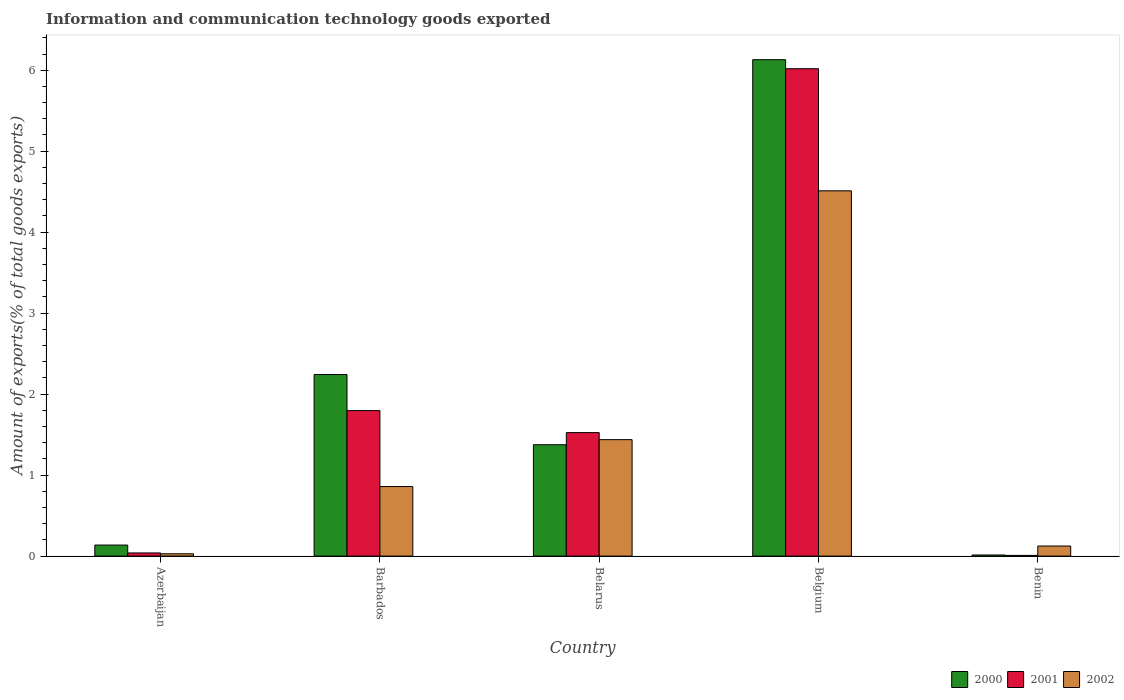How many different coloured bars are there?
Your answer should be compact. 3. How many bars are there on the 3rd tick from the right?
Your response must be concise. 3. What is the label of the 4th group of bars from the left?
Your answer should be very brief. Belgium. What is the amount of goods exported in 2002 in Benin?
Make the answer very short. 0.12. Across all countries, what is the maximum amount of goods exported in 2000?
Give a very brief answer. 6.13. Across all countries, what is the minimum amount of goods exported in 2002?
Offer a terse response. 0.03. In which country was the amount of goods exported in 2000 minimum?
Provide a short and direct response. Benin. What is the total amount of goods exported in 2002 in the graph?
Your response must be concise. 6.96. What is the difference between the amount of goods exported in 2000 in Barbados and that in Belgium?
Offer a very short reply. -3.89. What is the difference between the amount of goods exported in 2001 in Benin and the amount of goods exported in 2000 in Azerbaijan?
Give a very brief answer. -0.13. What is the average amount of goods exported in 2000 per country?
Ensure brevity in your answer.  1.98. What is the difference between the amount of goods exported of/in 2002 and amount of goods exported of/in 2001 in Belgium?
Give a very brief answer. -1.51. In how many countries, is the amount of goods exported in 2001 greater than 1.6 %?
Provide a succinct answer. 2. What is the ratio of the amount of goods exported in 2000 in Belgium to that in Benin?
Your answer should be compact. 443.09. Is the amount of goods exported in 2002 in Belarus less than that in Benin?
Give a very brief answer. No. What is the difference between the highest and the second highest amount of goods exported in 2001?
Offer a terse response. -0.27. What is the difference between the highest and the lowest amount of goods exported in 2002?
Your response must be concise. 4.48. In how many countries, is the amount of goods exported in 2000 greater than the average amount of goods exported in 2000 taken over all countries?
Keep it short and to the point. 2. What does the 1st bar from the left in Belgium represents?
Make the answer very short. 2000. Is it the case that in every country, the sum of the amount of goods exported in 2000 and amount of goods exported in 2001 is greater than the amount of goods exported in 2002?
Make the answer very short. No. How many bars are there?
Provide a succinct answer. 15. Are all the bars in the graph horizontal?
Make the answer very short. No. What is the difference between two consecutive major ticks on the Y-axis?
Keep it short and to the point. 1. Are the values on the major ticks of Y-axis written in scientific E-notation?
Provide a short and direct response. No. Where does the legend appear in the graph?
Your response must be concise. Bottom right. How are the legend labels stacked?
Your response must be concise. Horizontal. What is the title of the graph?
Keep it short and to the point. Information and communication technology goods exported. What is the label or title of the X-axis?
Make the answer very short. Country. What is the label or title of the Y-axis?
Your response must be concise. Amount of exports(% of total goods exports). What is the Amount of exports(% of total goods exports) in 2000 in Azerbaijan?
Give a very brief answer. 0.14. What is the Amount of exports(% of total goods exports) in 2001 in Azerbaijan?
Your answer should be very brief. 0.04. What is the Amount of exports(% of total goods exports) in 2002 in Azerbaijan?
Your response must be concise. 0.03. What is the Amount of exports(% of total goods exports) of 2000 in Barbados?
Your answer should be very brief. 2.24. What is the Amount of exports(% of total goods exports) in 2001 in Barbados?
Give a very brief answer. 1.8. What is the Amount of exports(% of total goods exports) of 2002 in Barbados?
Your response must be concise. 0.86. What is the Amount of exports(% of total goods exports) in 2000 in Belarus?
Your answer should be compact. 1.38. What is the Amount of exports(% of total goods exports) of 2001 in Belarus?
Offer a terse response. 1.53. What is the Amount of exports(% of total goods exports) of 2002 in Belarus?
Your response must be concise. 1.44. What is the Amount of exports(% of total goods exports) of 2000 in Belgium?
Ensure brevity in your answer.  6.13. What is the Amount of exports(% of total goods exports) in 2001 in Belgium?
Offer a terse response. 6.02. What is the Amount of exports(% of total goods exports) in 2002 in Belgium?
Keep it short and to the point. 4.51. What is the Amount of exports(% of total goods exports) in 2000 in Benin?
Make the answer very short. 0.01. What is the Amount of exports(% of total goods exports) of 2001 in Benin?
Make the answer very short. 0.01. What is the Amount of exports(% of total goods exports) of 2002 in Benin?
Offer a terse response. 0.12. Across all countries, what is the maximum Amount of exports(% of total goods exports) in 2000?
Offer a terse response. 6.13. Across all countries, what is the maximum Amount of exports(% of total goods exports) in 2001?
Provide a short and direct response. 6.02. Across all countries, what is the maximum Amount of exports(% of total goods exports) in 2002?
Provide a short and direct response. 4.51. Across all countries, what is the minimum Amount of exports(% of total goods exports) in 2000?
Provide a short and direct response. 0.01. Across all countries, what is the minimum Amount of exports(% of total goods exports) in 2001?
Your answer should be very brief. 0.01. Across all countries, what is the minimum Amount of exports(% of total goods exports) of 2002?
Offer a very short reply. 0.03. What is the total Amount of exports(% of total goods exports) of 2000 in the graph?
Your response must be concise. 9.9. What is the total Amount of exports(% of total goods exports) of 2001 in the graph?
Your response must be concise. 9.39. What is the total Amount of exports(% of total goods exports) in 2002 in the graph?
Your answer should be compact. 6.96. What is the difference between the Amount of exports(% of total goods exports) in 2000 in Azerbaijan and that in Barbados?
Ensure brevity in your answer.  -2.11. What is the difference between the Amount of exports(% of total goods exports) in 2001 in Azerbaijan and that in Barbados?
Provide a succinct answer. -1.76. What is the difference between the Amount of exports(% of total goods exports) of 2002 in Azerbaijan and that in Barbados?
Offer a very short reply. -0.83. What is the difference between the Amount of exports(% of total goods exports) of 2000 in Azerbaijan and that in Belarus?
Make the answer very short. -1.24. What is the difference between the Amount of exports(% of total goods exports) in 2001 in Azerbaijan and that in Belarus?
Give a very brief answer. -1.49. What is the difference between the Amount of exports(% of total goods exports) in 2002 in Azerbaijan and that in Belarus?
Ensure brevity in your answer.  -1.41. What is the difference between the Amount of exports(% of total goods exports) in 2000 in Azerbaijan and that in Belgium?
Offer a very short reply. -5.99. What is the difference between the Amount of exports(% of total goods exports) of 2001 in Azerbaijan and that in Belgium?
Your answer should be very brief. -5.98. What is the difference between the Amount of exports(% of total goods exports) in 2002 in Azerbaijan and that in Belgium?
Your response must be concise. -4.48. What is the difference between the Amount of exports(% of total goods exports) of 2000 in Azerbaijan and that in Benin?
Your answer should be very brief. 0.12. What is the difference between the Amount of exports(% of total goods exports) of 2001 in Azerbaijan and that in Benin?
Provide a succinct answer. 0.03. What is the difference between the Amount of exports(% of total goods exports) of 2002 in Azerbaijan and that in Benin?
Give a very brief answer. -0.1. What is the difference between the Amount of exports(% of total goods exports) of 2000 in Barbados and that in Belarus?
Make the answer very short. 0.87. What is the difference between the Amount of exports(% of total goods exports) of 2001 in Barbados and that in Belarus?
Your response must be concise. 0.27. What is the difference between the Amount of exports(% of total goods exports) of 2002 in Barbados and that in Belarus?
Make the answer very short. -0.58. What is the difference between the Amount of exports(% of total goods exports) of 2000 in Barbados and that in Belgium?
Give a very brief answer. -3.89. What is the difference between the Amount of exports(% of total goods exports) of 2001 in Barbados and that in Belgium?
Keep it short and to the point. -4.22. What is the difference between the Amount of exports(% of total goods exports) of 2002 in Barbados and that in Belgium?
Provide a succinct answer. -3.65. What is the difference between the Amount of exports(% of total goods exports) in 2000 in Barbados and that in Benin?
Make the answer very short. 2.23. What is the difference between the Amount of exports(% of total goods exports) of 2001 in Barbados and that in Benin?
Your answer should be very brief. 1.79. What is the difference between the Amount of exports(% of total goods exports) of 2002 in Barbados and that in Benin?
Keep it short and to the point. 0.73. What is the difference between the Amount of exports(% of total goods exports) in 2000 in Belarus and that in Belgium?
Your answer should be very brief. -4.75. What is the difference between the Amount of exports(% of total goods exports) in 2001 in Belarus and that in Belgium?
Provide a short and direct response. -4.49. What is the difference between the Amount of exports(% of total goods exports) of 2002 in Belarus and that in Belgium?
Keep it short and to the point. -3.07. What is the difference between the Amount of exports(% of total goods exports) in 2000 in Belarus and that in Benin?
Offer a very short reply. 1.36. What is the difference between the Amount of exports(% of total goods exports) of 2001 in Belarus and that in Benin?
Your response must be concise. 1.52. What is the difference between the Amount of exports(% of total goods exports) of 2002 in Belarus and that in Benin?
Your answer should be very brief. 1.31. What is the difference between the Amount of exports(% of total goods exports) of 2000 in Belgium and that in Benin?
Provide a succinct answer. 6.12. What is the difference between the Amount of exports(% of total goods exports) in 2001 in Belgium and that in Benin?
Keep it short and to the point. 6.01. What is the difference between the Amount of exports(% of total goods exports) in 2002 in Belgium and that in Benin?
Offer a very short reply. 4.39. What is the difference between the Amount of exports(% of total goods exports) in 2000 in Azerbaijan and the Amount of exports(% of total goods exports) in 2001 in Barbados?
Offer a terse response. -1.66. What is the difference between the Amount of exports(% of total goods exports) of 2000 in Azerbaijan and the Amount of exports(% of total goods exports) of 2002 in Barbados?
Your answer should be compact. -0.72. What is the difference between the Amount of exports(% of total goods exports) in 2001 in Azerbaijan and the Amount of exports(% of total goods exports) in 2002 in Barbados?
Your answer should be compact. -0.82. What is the difference between the Amount of exports(% of total goods exports) of 2000 in Azerbaijan and the Amount of exports(% of total goods exports) of 2001 in Belarus?
Your response must be concise. -1.39. What is the difference between the Amount of exports(% of total goods exports) in 2000 in Azerbaijan and the Amount of exports(% of total goods exports) in 2002 in Belarus?
Offer a very short reply. -1.3. What is the difference between the Amount of exports(% of total goods exports) in 2001 in Azerbaijan and the Amount of exports(% of total goods exports) in 2002 in Belarus?
Provide a succinct answer. -1.4. What is the difference between the Amount of exports(% of total goods exports) in 2000 in Azerbaijan and the Amount of exports(% of total goods exports) in 2001 in Belgium?
Offer a terse response. -5.88. What is the difference between the Amount of exports(% of total goods exports) in 2000 in Azerbaijan and the Amount of exports(% of total goods exports) in 2002 in Belgium?
Offer a terse response. -4.37. What is the difference between the Amount of exports(% of total goods exports) in 2001 in Azerbaijan and the Amount of exports(% of total goods exports) in 2002 in Belgium?
Your answer should be compact. -4.47. What is the difference between the Amount of exports(% of total goods exports) in 2000 in Azerbaijan and the Amount of exports(% of total goods exports) in 2001 in Benin?
Provide a succinct answer. 0.13. What is the difference between the Amount of exports(% of total goods exports) in 2000 in Azerbaijan and the Amount of exports(% of total goods exports) in 2002 in Benin?
Keep it short and to the point. 0.01. What is the difference between the Amount of exports(% of total goods exports) of 2001 in Azerbaijan and the Amount of exports(% of total goods exports) of 2002 in Benin?
Your answer should be very brief. -0.09. What is the difference between the Amount of exports(% of total goods exports) of 2000 in Barbados and the Amount of exports(% of total goods exports) of 2001 in Belarus?
Ensure brevity in your answer.  0.72. What is the difference between the Amount of exports(% of total goods exports) in 2000 in Barbados and the Amount of exports(% of total goods exports) in 2002 in Belarus?
Your response must be concise. 0.8. What is the difference between the Amount of exports(% of total goods exports) of 2001 in Barbados and the Amount of exports(% of total goods exports) of 2002 in Belarus?
Provide a short and direct response. 0.36. What is the difference between the Amount of exports(% of total goods exports) of 2000 in Barbados and the Amount of exports(% of total goods exports) of 2001 in Belgium?
Make the answer very short. -3.78. What is the difference between the Amount of exports(% of total goods exports) of 2000 in Barbados and the Amount of exports(% of total goods exports) of 2002 in Belgium?
Provide a succinct answer. -2.27. What is the difference between the Amount of exports(% of total goods exports) in 2001 in Barbados and the Amount of exports(% of total goods exports) in 2002 in Belgium?
Provide a short and direct response. -2.71. What is the difference between the Amount of exports(% of total goods exports) in 2000 in Barbados and the Amount of exports(% of total goods exports) in 2001 in Benin?
Offer a very short reply. 2.23. What is the difference between the Amount of exports(% of total goods exports) in 2000 in Barbados and the Amount of exports(% of total goods exports) in 2002 in Benin?
Your answer should be very brief. 2.12. What is the difference between the Amount of exports(% of total goods exports) in 2001 in Barbados and the Amount of exports(% of total goods exports) in 2002 in Benin?
Your answer should be very brief. 1.67. What is the difference between the Amount of exports(% of total goods exports) of 2000 in Belarus and the Amount of exports(% of total goods exports) of 2001 in Belgium?
Your answer should be very brief. -4.64. What is the difference between the Amount of exports(% of total goods exports) in 2000 in Belarus and the Amount of exports(% of total goods exports) in 2002 in Belgium?
Give a very brief answer. -3.14. What is the difference between the Amount of exports(% of total goods exports) in 2001 in Belarus and the Amount of exports(% of total goods exports) in 2002 in Belgium?
Give a very brief answer. -2.99. What is the difference between the Amount of exports(% of total goods exports) in 2000 in Belarus and the Amount of exports(% of total goods exports) in 2001 in Benin?
Offer a very short reply. 1.37. What is the difference between the Amount of exports(% of total goods exports) of 2000 in Belarus and the Amount of exports(% of total goods exports) of 2002 in Benin?
Keep it short and to the point. 1.25. What is the difference between the Amount of exports(% of total goods exports) of 2001 in Belarus and the Amount of exports(% of total goods exports) of 2002 in Benin?
Offer a very short reply. 1.4. What is the difference between the Amount of exports(% of total goods exports) in 2000 in Belgium and the Amount of exports(% of total goods exports) in 2001 in Benin?
Keep it short and to the point. 6.12. What is the difference between the Amount of exports(% of total goods exports) of 2000 in Belgium and the Amount of exports(% of total goods exports) of 2002 in Benin?
Offer a very short reply. 6.01. What is the difference between the Amount of exports(% of total goods exports) of 2001 in Belgium and the Amount of exports(% of total goods exports) of 2002 in Benin?
Ensure brevity in your answer.  5.89. What is the average Amount of exports(% of total goods exports) of 2000 per country?
Ensure brevity in your answer.  1.98. What is the average Amount of exports(% of total goods exports) of 2001 per country?
Keep it short and to the point. 1.88. What is the average Amount of exports(% of total goods exports) in 2002 per country?
Ensure brevity in your answer.  1.39. What is the difference between the Amount of exports(% of total goods exports) of 2000 and Amount of exports(% of total goods exports) of 2001 in Azerbaijan?
Your answer should be compact. 0.1. What is the difference between the Amount of exports(% of total goods exports) in 2000 and Amount of exports(% of total goods exports) in 2002 in Azerbaijan?
Provide a succinct answer. 0.11. What is the difference between the Amount of exports(% of total goods exports) in 2001 and Amount of exports(% of total goods exports) in 2002 in Azerbaijan?
Offer a terse response. 0.01. What is the difference between the Amount of exports(% of total goods exports) in 2000 and Amount of exports(% of total goods exports) in 2001 in Barbados?
Your response must be concise. 0.45. What is the difference between the Amount of exports(% of total goods exports) of 2000 and Amount of exports(% of total goods exports) of 2002 in Barbados?
Offer a terse response. 1.38. What is the difference between the Amount of exports(% of total goods exports) of 2001 and Amount of exports(% of total goods exports) of 2002 in Barbados?
Offer a terse response. 0.94. What is the difference between the Amount of exports(% of total goods exports) of 2000 and Amount of exports(% of total goods exports) of 2001 in Belarus?
Provide a succinct answer. -0.15. What is the difference between the Amount of exports(% of total goods exports) in 2000 and Amount of exports(% of total goods exports) in 2002 in Belarus?
Your response must be concise. -0.06. What is the difference between the Amount of exports(% of total goods exports) of 2001 and Amount of exports(% of total goods exports) of 2002 in Belarus?
Offer a terse response. 0.09. What is the difference between the Amount of exports(% of total goods exports) in 2000 and Amount of exports(% of total goods exports) in 2001 in Belgium?
Your answer should be very brief. 0.11. What is the difference between the Amount of exports(% of total goods exports) of 2000 and Amount of exports(% of total goods exports) of 2002 in Belgium?
Offer a very short reply. 1.62. What is the difference between the Amount of exports(% of total goods exports) in 2001 and Amount of exports(% of total goods exports) in 2002 in Belgium?
Provide a succinct answer. 1.51. What is the difference between the Amount of exports(% of total goods exports) of 2000 and Amount of exports(% of total goods exports) of 2001 in Benin?
Ensure brevity in your answer.  0.01. What is the difference between the Amount of exports(% of total goods exports) in 2000 and Amount of exports(% of total goods exports) in 2002 in Benin?
Ensure brevity in your answer.  -0.11. What is the difference between the Amount of exports(% of total goods exports) in 2001 and Amount of exports(% of total goods exports) in 2002 in Benin?
Your answer should be very brief. -0.12. What is the ratio of the Amount of exports(% of total goods exports) of 2000 in Azerbaijan to that in Barbados?
Keep it short and to the point. 0.06. What is the ratio of the Amount of exports(% of total goods exports) in 2001 in Azerbaijan to that in Barbados?
Keep it short and to the point. 0.02. What is the ratio of the Amount of exports(% of total goods exports) of 2002 in Azerbaijan to that in Barbados?
Offer a very short reply. 0.03. What is the ratio of the Amount of exports(% of total goods exports) in 2000 in Azerbaijan to that in Belarus?
Provide a succinct answer. 0.1. What is the ratio of the Amount of exports(% of total goods exports) of 2001 in Azerbaijan to that in Belarus?
Offer a very short reply. 0.03. What is the ratio of the Amount of exports(% of total goods exports) in 2002 in Azerbaijan to that in Belarus?
Offer a terse response. 0.02. What is the ratio of the Amount of exports(% of total goods exports) in 2000 in Azerbaijan to that in Belgium?
Provide a short and direct response. 0.02. What is the ratio of the Amount of exports(% of total goods exports) in 2001 in Azerbaijan to that in Belgium?
Keep it short and to the point. 0.01. What is the ratio of the Amount of exports(% of total goods exports) of 2002 in Azerbaijan to that in Belgium?
Offer a very short reply. 0.01. What is the ratio of the Amount of exports(% of total goods exports) of 2000 in Azerbaijan to that in Benin?
Ensure brevity in your answer.  9.86. What is the ratio of the Amount of exports(% of total goods exports) of 2001 in Azerbaijan to that in Benin?
Your answer should be very brief. 4.45. What is the ratio of the Amount of exports(% of total goods exports) of 2002 in Azerbaijan to that in Benin?
Provide a succinct answer. 0.23. What is the ratio of the Amount of exports(% of total goods exports) in 2000 in Barbados to that in Belarus?
Provide a succinct answer. 1.63. What is the ratio of the Amount of exports(% of total goods exports) of 2001 in Barbados to that in Belarus?
Offer a very short reply. 1.18. What is the ratio of the Amount of exports(% of total goods exports) of 2002 in Barbados to that in Belarus?
Your answer should be compact. 0.6. What is the ratio of the Amount of exports(% of total goods exports) in 2000 in Barbados to that in Belgium?
Make the answer very short. 0.37. What is the ratio of the Amount of exports(% of total goods exports) in 2001 in Barbados to that in Belgium?
Make the answer very short. 0.3. What is the ratio of the Amount of exports(% of total goods exports) of 2002 in Barbados to that in Belgium?
Your response must be concise. 0.19. What is the ratio of the Amount of exports(% of total goods exports) of 2000 in Barbados to that in Benin?
Keep it short and to the point. 162.08. What is the ratio of the Amount of exports(% of total goods exports) of 2001 in Barbados to that in Benin?
Your answer should be very brief. 205.42. What is the ratio of the Amount of exports(% of total goods exports) of 2002 in Barbados to that in Benin?
Give a very brief answer. 6.91. What is the ratio of the Amount of exports(% of total goods exports) of 2000 in Belarus to that in Belgium?
Offer a terse response. 0.22. What is the ratio of the Amount of exports(% of total goods exports) of 2001 in Belarus to that in Belgium?
Give a very brief answer. 0.25. What is the ratio of the Amount of exports(% of total goods exports) of 2002 in Belarus to that in Belgium?
Your response must be concise. 0.32. What is the ratio of the Amount of exports(% of total goods exports) of 2000 in Belarus to that in Benin?
Your answer should be compact. 99.4. What is the ratio of the Amount of exports(% of total goods exports) in 2001 in Belarus to that in Benin?
Your response must be concise. 174.35. What is the ratio of the Amount of exports(% of total goods exports) of 2002 in Belarus to that in Benin?
Provide a succinct answer. 11.56. What is the ratio of the Amount of exports(% of total goods exports) in 2000 in Belgium to that in Benin?
Your answer should be compact. 443.09. What is the ratio of the Amount of exports(% of total goods exports) in 2001 in Belgium to that in Benin?
Ensure brevity in your answer.  688.06. What is the ratio of the Amount of exports(% of total goods exports) in 2002 in Belgium to that in Benin?
Offer a terse response. 36.26. What is the difference between the highest and the second highest Amount of exports(% of total goods exports) of 2000?
Offer a very short reply. 3.89. What is the difference between the highest and the second highest Amount of exports(% of total goods exports) in 2001?
Ensure brevity in your answer.  4.22. What is the difference between the highest and the second highest Amount of exports(% of total goods exports) of 2002?
Offer a very short reply. 3.07. What is the difference between the highest and the lowest Amount of exports(% of total goods exports) in 2000?
Provide a short and direct response. 6.12. What is the difference between the highest and the lowest Amount of exports(% of total goods exports) in 2001?
Your answer should be very brief. 6.01. What is the difference between the highest and the lowest Amount of exports(% of total goods exports) of 2002?
Your answer should be compact. 4.48. 